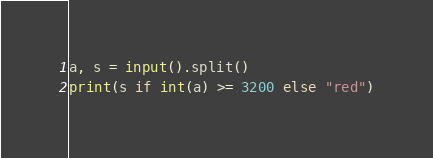Convert code to text. <code><loc_0><loc_0><loc_500><loc_500><_Python_>a, s = input().split()
print(s if int(a) >= 3200 else "red")</code> 